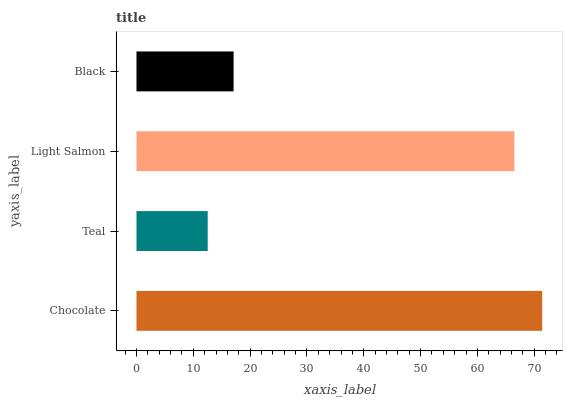Is Teal the minimum?
Answer yes or no. Yes. Is Chocolate the maximum?
Answer yes or no. Yes. Is Light Salmon the minimum?
Answer yes or no. No. Is Light Salmon the maximum?
Answer yes or no. No. Is Light Salmon greater than Teal?
Answer yes or no. Yes. Is Teal less than Light Salmon?
Answer yes or no. Yes. Is Teal greater than Light Salmon?
Answer yes or no. No. Is Light Salmon less than Teal?
Answer yes or no. No. Is Light Salmon the high median?
Answer yes or no. Yes. Is Black the low median?
Answer yes or no. Yes. Is Chocolate the high median?
Answer yes or no. No. Is Light Salmon the low median?
Answer yes or no. No. 